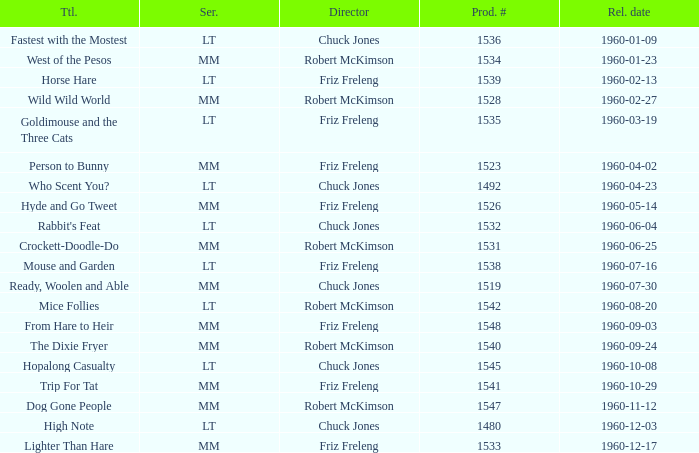What is the production number of From Hare to Heir? 1548.0. 